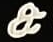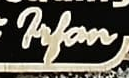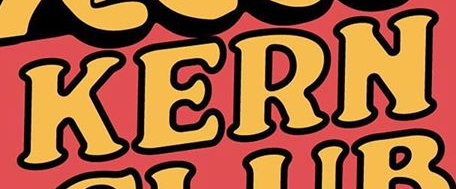What text is displayed in these images sequentially, separated by a semicolon? &; Filan; KERN 